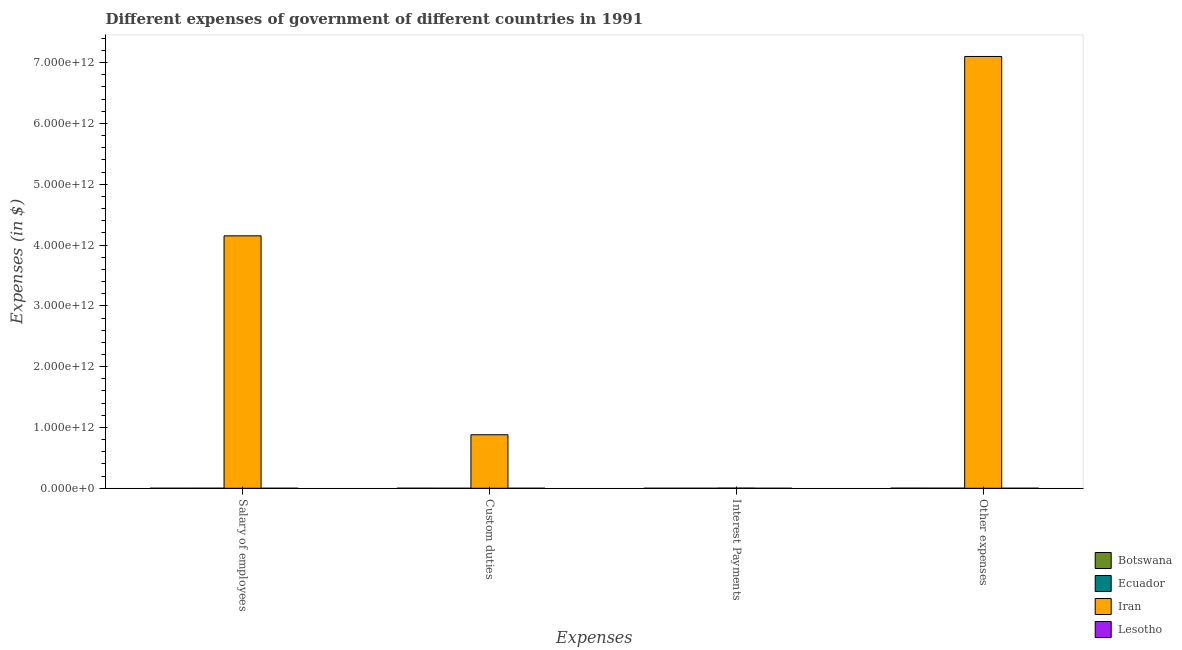How many different coloured bars are there?
Ensure brevity in your answer.  4. How many groups of bars are there?
Your answer should be very brief. 4. How many bars are there on the 2nd tick from the right?
Make the answer very short. 4. What is the label of the 2nd group of bars from the left?
Make the answer very short. Custom duties. What is the amount spent on salary of employees in Botswana?
Your answer should be very brief. 7.39e+08. Across all countries, what is the maximum amount spent on other expenses?
Offer a terse response. 7.10e+12. Across all countries, what is the minimum amount spent on custom duties?
Provide a short and direct response. 2.26e+08. In which country was the amount spent on custom duties maximum?
Give a very brief answer. Iran. In which country was the amount spent on salary of employees minimum?
Provide a succinct answer. Lesotho. What is the total amount spent on custom duties in the graph?
Offer a very short reply. 8.81e+11. What is the difference between the amount spent on salary of employees in Botswana and that in Lesotho?
Offer a terse response. 4.57e+08. What is the difference between the amount spent on salary of employees in Ecuador and the amount spent on other expenses in Iran?
Ensure brevity in your answer.  -7.10e+12. What is the average amount spent on custom duties per country?
Offer a very short reply. 2.20e+11. What is the difference between the amount spent on other expenses and amount spent on interest payments in Iran?
Your answer should be compact. 7.10e+12. What is the ratio of the amount spent on other expenses in Botswana to that in Iran?
Offer a very short reply. 0. What is the difference between the highest and the second highest amount spent on interest payments?
Offer a terse response. 2.60e+09. What is the difference between the highest and the lowest amount spent on custom duties?
Offer a terse response. 8.80e+11. Is it the case that in every country, the sum of the amount spent on interest payments and amount spent on custom duties is greater than the sum of amount spent on other expenses and amount spent on salary of employees?
Your response must be concise. No. What does the 3rd bar from the left in Other expenses represents?
Give a very brief answer. Iran. What does the 2nd bar from the right in Custom duties represents?
Keep it short and to the point. Iran. How many bars are there?
Give a very brief answer. 16. What is the difference between two consecutive major ticks on the Y-axis?
Offer a very short reply. 1.00e+12. Does the graph contain any zero values?
Give a very brief answer. No. Does the graph contain grids?
Your answer should be very brief. No. Where does the legend appear in the graph?
Provide a short and direct response. Bottom right. How many legend labels are there?
Your response must be concise. 4. How are the legend labels stacked?
Offer a terse response. Vertical. What is the title of the graph?
Offer a terse response. Different expenses of government of different countries in 1991. What is the label or title of the X-axis?
Your answer should be very brief. Expenses. What is the label or title of the Y-axis?
Ensure brevity in your answer.  Expenses (in $). What is the Expenses (in $) in Botswana in Salary of employees?
Provide a short and direct response. 7.39e+08. What is the Expenses (in $) in Ecuador in Salary of employees?
Ensure brevity in your answer.  7.72e+08. What is the Expenses (in $) in Iran in Salary of employees?
Keep it short and to the point. 4.15e+12. What is the Expenses (in $) of Lesotho in Salary of employees?
Offer a terse response. 2.81e+08. What is the Expenses (in $) of Botswana in Custom duties?
Offer a terse response. 7.62e+08. What is the Expenses (in $) of Ecuador in Custom duties?
Ensure brevity in your answer.  2.26e+08. What is the Expenses (in $) of Iran in Custom duties?
Keep it short and to the point. 8.80e+11. What is the Expenses (in $) of Lesotho in Custom duties?
Your answer should be compact. 4.24e+08. What is the Expenses (in $) in Botswana in Interest Payments?
Your answer should be compact. 6.07e+07. What is the Expenses (in $) of Ecuador in Interest Payments?
Provide a succinct answer. 3.99e+08. What is the Expenses (in $) in Iran in Interest Payments?
Offer a terse response. 3.00e+09. What is the Expenses (in $) in Lesotho in Interest Payments?
Give a very brief answer. 8.45e+07. What is the Expenses (in $) of Botswana in Other expenses?
Make the answer very short. 2.22e+09. What is the Expenses (in $) of Ecuador in Other expenses?
Provide a succinct answer. 1.68e+09. What is the Expenses (in $) of Iran in Other expenses?
Provide a succinct answer. 7.10e+12. What is the Expenses (in $) of Lesotho in Other expenses?
Ensure brevity in your answer.  6.37e+08. Across all Expenses, what is the maximum Expenses (in $) in Botswana?
Your response must be concise. 2.22e+09. Across all Expenses, what is the maximum Expenses (in $) in Ecuador?
Offer a terse response. 1.68e+09. Across all Expenses, what is the maximum Expenses (in $) in Iran?
Provide a short and direct response. 7.10e+12. Across all Expenses, what is the maximum Expenses (in $) in Lesotho?
Give a very brief answer. 6.37e+08. Across all Expenses, what is the minimum Expenses (in $) of Botswana?
Ensure brevity in your answer.  6.07e+07. Across all Expenses, what is the minimum Expenses (in $) in Ecuador?
Give a very brief answer. 2.26e+08. Across all Expenses, what is the minimum Expenses (in $) of Iran?
Your response must be concise. 3.00e+09. Across all Expenses, what is the minimum Expenses (in $) in Lesotho?
Keep it short and to the point. 8.45e+07. What is the total Expenses (in $) of Botswana in the graph?
Ensure brevity in your answer.  3.78e+09. What is the total Expenses (in $) in Ecuador in the graph?
Offer a terse response. 3.07e+09. What is the total Expenses (in $) of Iran in the graph?
Provide a short and direct response. 1.21e+13. What is the total Expenses (in $) in Lesotho in the graph?
Your response must be concise. 1.43e+09. What is the difference between the Expenses (in $) in Botswana in Salary of employees and that in Custom duties?
Keep it short and to the point. -2.27e+07. What is the difference between the Expenses (in $) in Ecuador in Salary of employees and that in Custom duties?
Your response must be concise. 5.46e+08. What is the difference between the Expenses (in $) in Iran in Salary of employees and that in Custom duties?
Make the answer very short. 3.27e+12. What is the difference between the Expenses (in $) of Lesotho in Salary of employees and that in Custom duties?
Make the answer very short. -1.43e+08. What is the difference between the Expenses (in $) in Botswana in Salary of employees and that in Interest Payments?
Give a very brief answer. 6.78e+08. What is the difference between the Expenses (in $) in Ecuador in Salary of employees and that in Interest Payments?
Your answer should be very brief. 3.73e+08. What is the difference between the Expenses (in $) in Iran in Salary of employees and that in Interest Payments?
Make the answer very short. 4.15e+12. What is the difference between the Expenses (in $) of Lesotho in Salary of employees and that in Interest Payments?
Offer a terse response. 1.97e+08. What is the difference between the Expenses (in $) of Botswana in Salary of employees and that in Other expenses?
Keep it short and to the point. -1.48e+09. What is the difference between the Expenses (in $) in Ecuador in Salary of employees and that in Other expenses?
Ensure brevity in your answer.  -9.05e+08. What is the difference between the Expenses (in $) in Iran in Salary of employees and that in Other expenses?
Keep it short and to the point. -2.95e+12. What is the difference between the Expenses (in $) of Lesotho in Salary of employees and that in Other expenses?
Your answer should be compact. -3.55e+08. What is the difference between the Expenses (in $) of Botswana in Custom duties and that in Interest Payments?
Your response must be concise. 7.01e+08. What is the difference between the Expenses (in $) of Ecuador in Custom duties and that in Interest Payments?
Give a very brief answer. -1.73e+08. What is the difference between the Expenses (in $) in Iran in Custom duties and that in Interest Payments?
Give a very brief answer. 8.77e+11. What is the difference between the Expenses (in $) in Lesotho in Custom duties and that in Interest Payments?
Offer a very short reply. 3.40e+08. What is the difference between the Expenses (in $) in Botswana in Custom duties and that in Other expenses?
Give a very brief answer. -1.46e+09. What is the difference between the Expenses (in $) in Ecuador in Custom duties and that in Other expenses?
Ensure brevity in your answer.  -1.45e+09. What is the difference between the Expenses (in $) in Iran in Custom duties and that in Other expenses?
Your answer should be compact. -6.22e+12. What is the difference between the Expenses (in $) in Lesotho in Custom duties and that in Other expenses?
Your answer should be very brief. -2.13e+08. What is the difference between the Expenses (in $) in Botswana in Interest Payments and that in Other expenses?
Your answer should be compact. -2.16e+09. What is the difference between the Expenses (in $) of Ecuador in Interest Payments and that in Other expenses?
Make the answer very short. -1.28e+09. What is the difference between the Expenses (in $) in Iran in Interest Payments and that in Other expenses?
Provide a succinct answer. -7.10e+12. What is the difference between the Expenses (in $) of Lesotho in Interest Payments and that in Other expenses?
Make the answer very short. -5.52e+08. What is the difference between the Expenses (in $) in Botswana in Salary of employees and the Expenses (in $) in Ecuador in Custom duties?
Make the answer very short. 5.13e+08. What is the difference between the Expenses (in $) of Botswana in Salary of employees and the Expenses (in $) of Iran in Custom duties?
Ensure brevity in your answer.  -8.79e+11. What is the difference between the Expenses (in $) of Botswana in Salary of employees and the Expenses (in $) of Lesotho in Custom duties?
Your answer should be very brief. 3.15e+08. What is the difference between the Expenses (in $) in Ecuador in Salary of employees and the Expenses (in $) in Iran in Custom duties?
Offer a very short reply. -8.79e+11. What is the difference between the Expenses (in $) of Ecuador in Salary of employees and the Expenses (in $) of Lesotho in Custom duties?
Provide a short and direct response. 3.48e+08. What is the difference between the Expenses (in $) in Iran in Salary of employees and the Expenses (in $) in Lesotho in Custom duties?
Give a very brief answer. 4.15e+12. What is the difference between the Expenses (in $) in Botswana in Salary of employees and the Expenses (in $) in Ecuador in Interest Payments?
Give a very brief answer. 3.40e+08. What is the difference between the Expenses (in $) of Botswana in Salary of employees and the Expenses (in $) of Iran in Interest Payments?
Provide a succinct answer. -2.26e+09. What is the difference between the Expenses (in $) of Botswana in Salary of employees and the Expenses (in $) of Lesotho in Interest Payments?
Your answer should be compact. 6.54e+08. What is the difference between the Expenses (in $) in Ecuador in Salary of employees and the Expenses (in $) in Iran in Interest Payments?
Offer a very short reply. -2.23e+09. What is the difference between the Expenses (in $) of Ecuador in Salary of employees and the Expenses (in $) of Lesotho in Interest Payments?
Ensure brevity in your answer.  6.88e+08. What is the difference between the Expenses (in $) of Iran in Salary of employees and the Expenses (in $) of Lesotho in Interest Payments?
Offer a very short reply. 4.15e+12. What is the difference between the Expenses (in $) of Botswana in Salary of employees and the Expenses (in $) of Ecuador in Other expenses?
Your response must be concise. -9.38e+08. What is the difference between the Expenses (in $) in Botswana in Salary of employees and the Expenses (in $) in Iran in Other expenses?
Make the answer very short. -7.10e+12. What is the difference between the Expenses (in $) in Botswana in Salary of employees and the Expenses (in $) in Lesotho in Other expenses?
Provide a short and direct response. 1.02e+08. What is the difference between the Expenses (in $) in Ecuador in Salary of employees and the Expenses (in $) in Iran in Other expenses?
Provide a short and direct response. -7.10e+12. What is the difference between the Expenses (in $) of Ecuador in Salary of employees and the Expenses (in $) of Lesotho in Other expenses?
Your answer should be compact. 1.35e+08. What is the difference between the Expenses (in $) of Iran in Salary of employees and the Expenses (in $) of Lesotho in Other expenses?
Offer a very short reply. 4.15e+12. What is the difference between the Expenses (in $) in Botswana in Custom duties and the Expenses (in $) in Ecuador in Interest Payments?
Provide a succinct answer. 3.63e+08. What is the difference between the Expenses (in $) in Botswana in Custom duties and the Expenses (in $) in Iran in Interest Payments?
Make the answer very short. -2.24e+09. What is the difference between the Expenses (in $) in Botswana in Custom duties and the Expenses (in $) in Lesotho in Interest Payments?
Your response must be concise. 6.77e+08. What is the difference between the Expenses (in $) in Ecuador in Custom duties and the Expenses (in $) in Iran in Interest Payments?
Offer a terse response. -2.77e+09. What is the difference between the Expenses (in $) in Ecuador in Custom duties and the Expenses (in $) in Lesotho in Interest Payments?
Your answer should be very brief. 1.42e+08. What is the difference between the Expenses (in $) of Iran in Custom duties and the Expenses (in $) of Lesotho in Interest Payments?
Keep it short and to the point. 8.80e+11. What is the difference between the Expenses (in $) in Botswana in Custom duties and the Expenses (in $) in Ecuador in Other expenses?
Keep it short and to the point. -9.15e+08. What is the difference between the Expenses (in $) in Botswana in Custom duties and the Expenses (in $) in Iran in Other expenses?
Give a very brief answer. -7.10e+12. What is the difference between the Expenses (in $) in Botswana in Custom duties and the Expenses (in $) in Lesotho in Other expenses?
Give a very brief answer. 1.25e+08. What is the difference between the Expenses (in $) of Ecuador in Custom duties and the Expenses (in $) of Iran in Other expenses?
Make the answer very short. -7.10e+12. What is the difference between the Expenses (in $) in Ecuador in Custom duties and the Expenses (in $) in Lesotho in Other expenses?
Your answer should be very brief. -4.11e+08. What is the difference between the Expenses (in $) of Iran in Custom duties and the Expenses (in $) of Lesotho in Other expenses?
Ensure brevity in your answer.  8.79e+11. What is the difference between the Expenses (in $) of Botswana in Interest Payments and the Expenses (in $) of Ecuador in Other expenses?
Your response must be concise. -1.62e+09. What is the difference between the Expenses (in $) in Botswana in Interest Payments and the Expenses (in $) in Iran in Other expenses?
Your answer should be compact. -7.10e+12. What is the difference between the Expenses (in $) of Botswana in Interest Payments and the Expenses (in $) of Lesotho in Other expenses?
Your answer should be compact. -5.76e+08. What is the difference between the Expenses (in $) of Ecuador in Interest Payments and the Expenses (in $) of Iran in Other expenses?
Your response must be concise. -7.10e+12. What is the difference between the Expenses (in $) in Ecuador in Interest Payments and the Expenses (in $) in Lesotho in Other expenses?
Your answer should be compact. -2.38e+08. What is the difference between the Expenses (in $) of Iran in Interest Payments and the Expenses (in $) of Lesotho in Other expenses?
Ensure brevity in your answer.  2.36e+09. What is the average Expenses (in $) in Botswana per Expenses?
Make the answer very short. 9.45e+08. What is the average Expenses (in $) in Ecuador per Expenses?
Give a very brief answer. 7.68e+08. What is the average Expenses (in $) of Iran per Expenses?
Provide a short and direct response. 3.03e+12. What is the average Expenses (in $) in Lesotho per Expenses?
Your answer should be very brief. 3.57e+08. What is the difference between the Expenses (in $) in Botswana and Expenses (in $) in Ecuador in Salary of employees?
Your answer should be compact. -3.31e+07. What is the difference between the Expenses (in $) in Botswana and Expenses (in $) in Iran in Salary of employees?
Ensure brevity in your answer.  -4.15e+12. What is the difference between the Expenses (in $) of Botswana and Expenses (in $) of Lesotho in Salary of employees?
Keep it short and to the point. 4.57e+08. What is the difference between the Expenses (in $) of Ecuador and Expenses (in $) of Iran in Salary of employees?
Ensure brevity in your answer.  -4.15e+12. What is the difference between the Expenses (in $) in Ecuador and Expenses (in $) in Lesotho in Salary of employees?
Offer a terse response. 4.91e+08. What is the difference between the Expenses (in $) in Iran and Expenses (in $) in Lesotho in Salary of employees?
Offer a very short reply. 4.15e+12. What is the difference between the Expenses (in $) in Botswana and Expenses (in $) in Ecuador in Custom duties?
Your answer should be compact. 5.36e+08. What is the difference between the Expenses (in $) in Botswana and Expenses (in $) in Iran in Custom duties?
Ensure brevity in your answer.  -8.79e+11. What is the difference between the Expenses (in $) of Botswana and Expenses (in $) of Lesotho in Custom duties?
Provide a succinct answer. 3.38e+08. What is the difference between the Expenses (in $) in Ecuador and Expenses (in $) in Iran in Custom duties?
Your answer should be very brief. -8.80e+11. What is the difference between the Expenses (in $) of Ecuador and Expenses (in $) of Lesotho in Custom duties?
Offer a very short reply. -1.98e+08. What is the difference between the Expenses (in $) of Iran and Expenses (in $) of Lesotho in Custom duties?
Ensure brevity in your answer.  8.80e+11. What is the difference between the Expenses (in $) of Botswana and Expenses (in $) of Ecuador in Interest Payments?
Your answer should be compact. -3.38e+08. What is the difference between the Expenses (in $) of Botswana and Expenses (in $) of Iran in Interest Payments?
Provide a succinct answer. -2.94e+09. What is the difference between the Expenses (in $) in Botswana and Expenses (in $) in Lesotho in Interest Payments?
Give a very brief answer. -2.38e+07. What is the difference between the Expenses (in $) in Ecuador and Expenses (in $) in Iran in Interest Payments?
Provide a short and direct response. -2.60e+09. What is the difference between the Expenses (in $) in Ecuador and Expenses (in $) in Lesotho in Interest Payments?
Provide a short and direct response. 3.15e+08. What is the difference between the Expenses (in $) in Iran and Expenses (in $) in Lesotho in Interest Payments?
Your answer should be compact. 2.92e+09. What is the difference between the Expenses (in $) in Botswana and Expenses (in $) in Ecuador in Other expenses?
Your answer should be very brief. 5.42e+08. What is the difference between the Expenses (in $) of Botswana and Expenses (in $) of Iran in Other expenses?
Keep it short and to the point. -7.10e+12. What is the difference between the Expenses (in $) of Botswana and Expenses (in $) of Lesotho in Other expenses?
Your answer should be compact. 1.58e+09. What is the difference between the Expenses (in $) of Ecuador and Expenses (in $) of Iran in Other expenses?
Ensure brevity in your answer.  -7.10e+12. What is the difference between the Expenses (in $) of Ecuador and Expenses (in $) of Lesotho in Other expenses?
Your answer should be compact. 1.04e+09. What is the difference between the Expenses (in $) of Iran and Expenses (in $) of Lesotho in Other expenses?
Offer a very short reply. 7.10e+12. What is the ratio of the Expenses (in $) of Botswana in Salary of employees to that in Custom duties?
Keep it short and to the point. 0.97. What is the ratio of the Expenses (in $) of Ecuador in Salary of employees to that in Custom duties?
Ensure brevity in your answer.  3.42. What is the ratio of the Expenses (in $) of Iran in Salary of employees to that in Custom duties?
Your answer should be compact. 4.72. What is the ratio of the Expenses (in $) of Lesotho in Salary of employees to that in Custom duties?
Offer a terse response. 0.66. What is the ratio of the Expenses (in $) of Botswana in Salary of employees to that in Interest Payments?
Provide a short and direct response. 12.17. What is the ratio of the Expenses (in $) in Ecuador in Salary of employees to that in Interest Payments?
Your answer should be very brief. 1.93. What is the ratio of the Expenses (in $) of Iran in Salary of employees to that in Interest Payments?
Provide a succinct answer. 1384. What is the ratio of the Expenses (in $) of Lesotho in Salary of employees to that in Interest Payments?
Offer a terse response. 3.33. What is the ratio of the Expenses (in $) of Botswana in Salary of employees to that in Other expenses?
Give a very brief answer. 0.33. What is the ratio of the Expenses (in $) of Ecuador in Salary of employees to that in Other expenses?
Offer a terse response. 0.46. What is the ratio of the Expenses (in $) in Iran in Salary of employees to that in Other expenses?
Your answer should be very brief. 0.58. What is the ratio of the Expenses (in $) in Lesotho in Salary of employees to that in Other expenses?
Offer a terse response. 0.44. What is the ratio of the Expenses (in $) in Botswana in Custom duties to that in Interest Payments?
Give a very brief answer. 12.55. What is the ratio of the Expenses (in $) of Ecuador in Custom duties to that in Interest Payments?
Provide a short and direct response. 0.57. What is the ratio of the Expenses (in $) of Iran in Custom duties to that in Interest Payments?
Give a very brief answer. 293.33. What is the ratio of the Expenses (in $) in Lesotho in Custom duties to that in Interest Payments?
Your response must be concise. 5.02. What is the ratio of the Expenses (in $) of Botswana in Custom duties to that in Other expenses?
Make the answer very short. 0.34. What is the ratio of the Expenses (in $) of Ecuador in Custom duties to that in Other expenses?
Your answer should be compact. 0.13. What is the ratio of the Expenses (in $) of Iran in Custom duties to that in Other expenses?
Keep it short and to the point. 0.12. What is the ratio of the Expenses (in $) in Lesotho in Custom duties to that in Other expenses?
Keep it short and to the point. 0.67. What is the ratio of the Expenses (in $) of Botswana in Interest Payments to that in Other expenses?
Your answer should be compact. 0.03. What is the ratio of the Expenses (in $) in Ecuador in Interest Payments to that in Other expenses?
Provide a short and direct response. 0.24. What is the ratio of the Expenses (in $) of Lesotho in Interest Payments to that in Other expenses?
Your answer should be very brief. 0.13. What is the difference between the highest and the second highest Expenses (in $) of Botswana?
Your answer should be compact. 1.46e+09. What is the difference between the highest and the second highest Expenses (in $) in Ecuador?
Ensure brevity in your answer.  9.05e+08. What is the difference between the highest and the second highest Expenses (in $) in Iran?
Provide a succinct answer. 2.95e+12. What is the difference between the highest and the second highest Expenses (in $) in Lesotho?
Your answer should be very brief. 2.13e+08. What is the difference between the highest and the lowest Expenses (in $) in Botswana?
Offer a terse response. 2.16e+09. What is the difference between the highest and the lowest Expenses (in $) of Ecuador?
Your answer should be very brief. 1.45e+09. What is the difference between the highest and the lowest Expenses (in $) in Iran?
Make the answer very short. 7.10e+12. What is the difference between the highest and the lowest Expenses (in $) in Lesotho?
Give a very brief answer. 5.52e+08. 